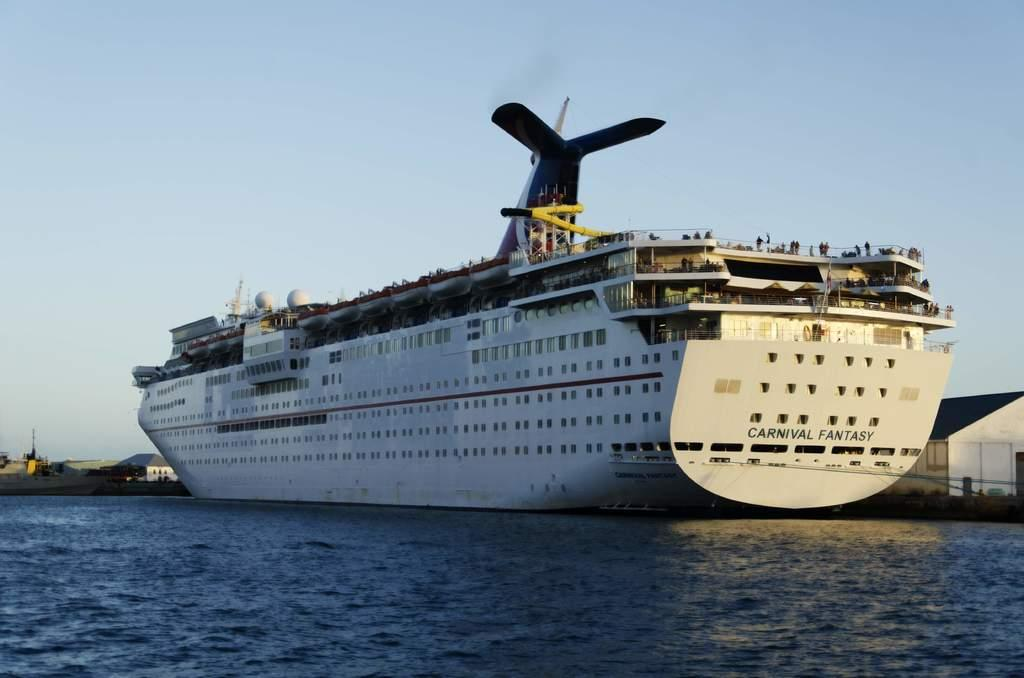<image>
Provide a brief description of the given image. A Carnival Fantasy cruise ship is docked next to shore. 